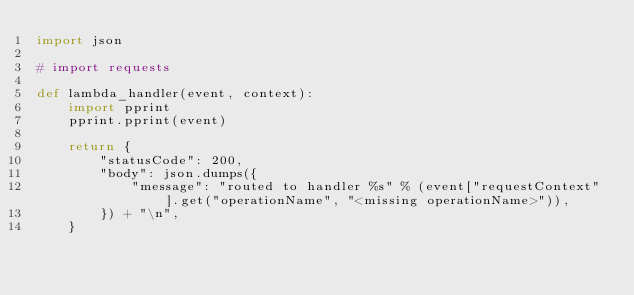Convert code to text. <code><loc_0><loc_0><loc_500><loc_500><_Python_>import json

# import requests

def lambda_handler(event, context):
    import pprint
    pprint.pprint(event)

    return {
        "statusCode": 200,
        "body": json.dumps({
            "message": "routed to handler %s" % (event["requestContext"].get("operationName", "<missing operationName>")),
        }) + "\n",
    }
</code> 